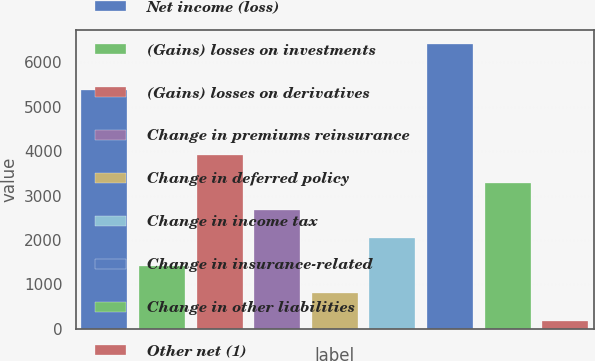Convert chart. <chart><loc_0><loc_0><loc_500><loc_500><bar_chart><fcel>Net income (loss)<fcel>(Gains) losses on investments<fcel>(Gains) losses on derivatives<fcel>Change in premiums reinsurance<fcel>Change in deferred policy<fcel>Change in income tax<fcel>Change in insurance-related<fcel>Change in other liabilities<fcel>Other net (1)<nl><fcel>5385<fcel>1418.4<fcel>3913.2<fcel>2665.8<fcel>794.7<fcel>2042.1<fcel>6408<fcel>3289.5<fcel>171<nl></chart> 